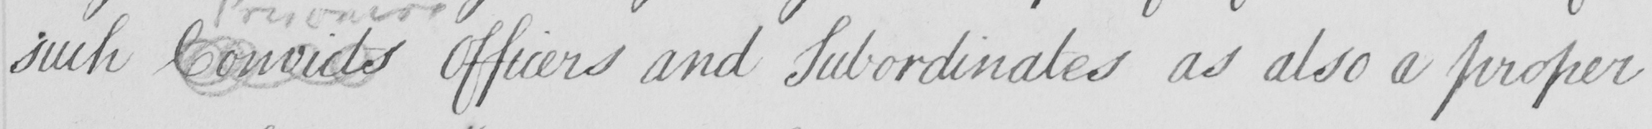Can you tell me what this handwritten text says? such Convicts Officers and Subordinates as also a proper 